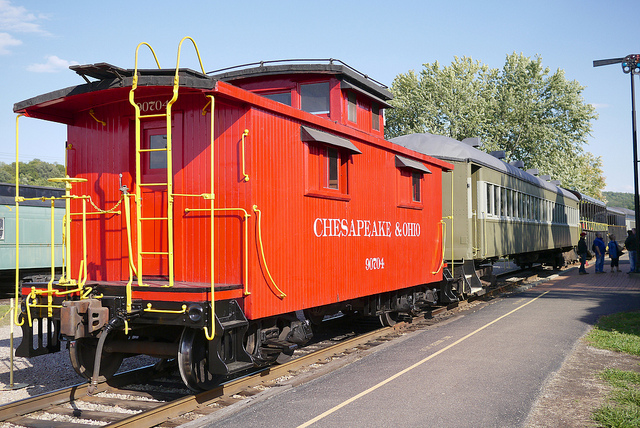Read and extract the text from this image. CHESAPEAKE OHIO 90704 &amp; 